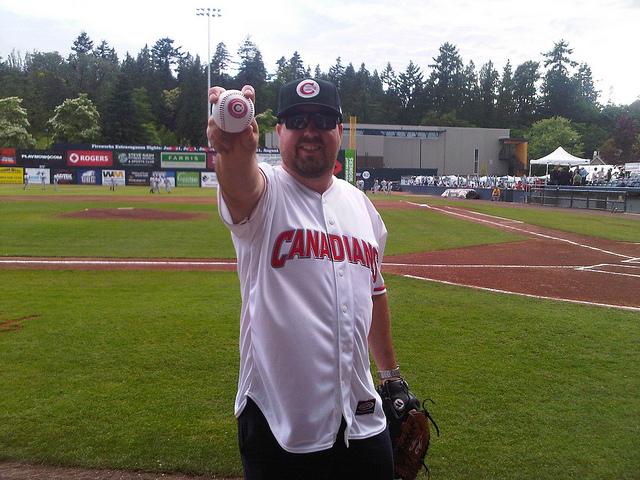Is the man wearing a hat?
Be succinct. Yes. What is the man holding?
Keep it brief. Baseball. What country is he likely from?
Keep it brief. Canada. 